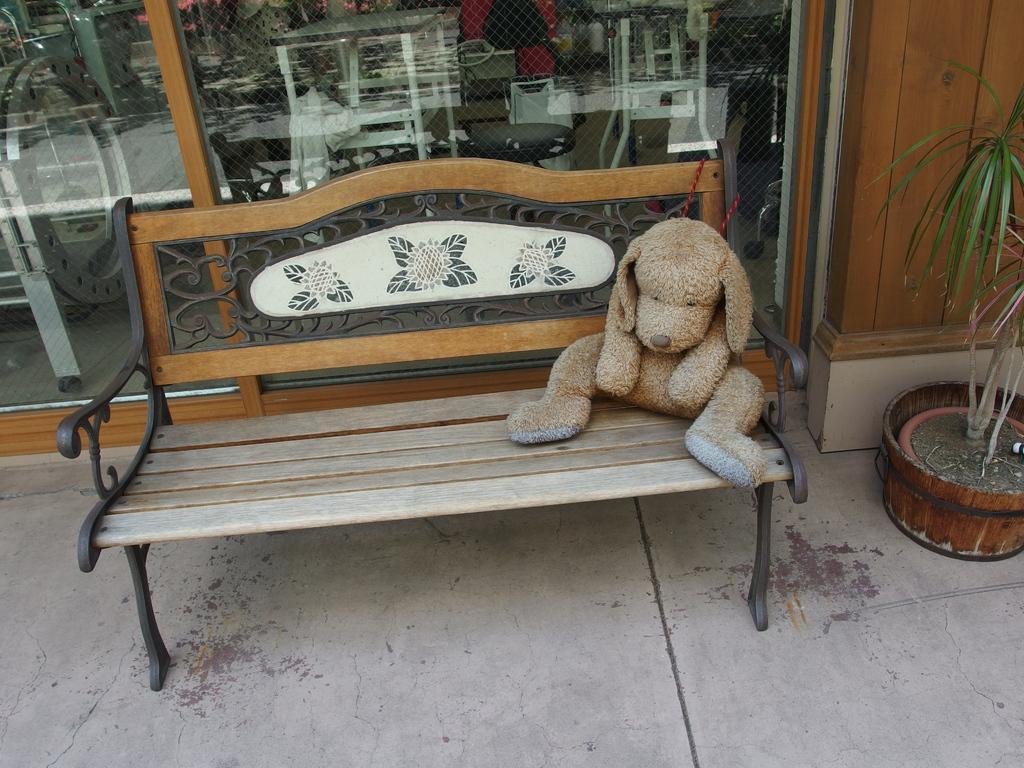Could you give a brief overview of what you see in this image? This picture shows a bench and a toy on it and we see a plant. 